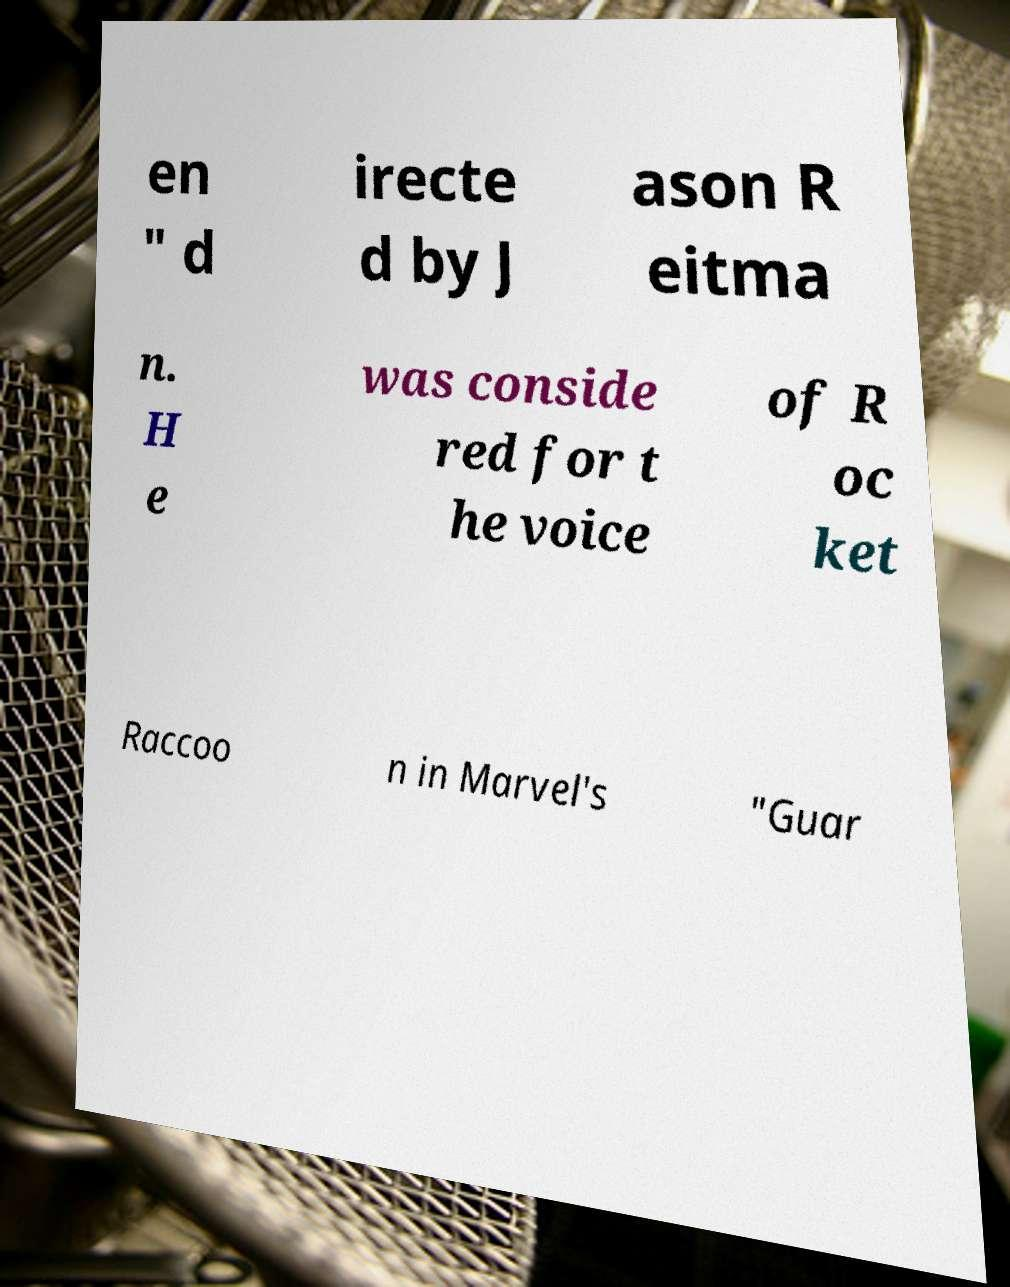Could you extract and type out the text from this image? en " d irecte d by J ason R eitma n. H e was conside red for t he voice of R oc ket Raccoo n in Marvel's "Guar 